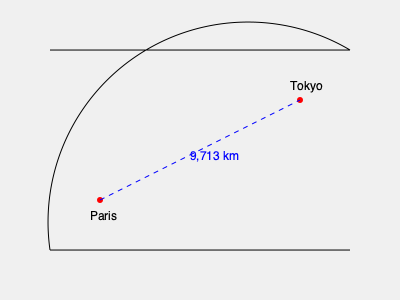Your partner, an avid traveler, is planning a direct flight from Paris to Tokyo. Using the world map provided, which shows the curved surface of the Earth, calculate the approximate great circle distance between these two cities if the scale of the map indicates that 1 cm represents 1,000 km and the straight-line distance on the map is 9.713 cm. To solve this problem, we'll follow these steps:

1. Understand the concept of great circle distance:
   The shortest distance between two points on a sphere (like Earth) follows a great circle path, which appears curved on a flat map.

2. Recognize the given information:
   - The map shows a curved Earth surface
   - Scale: 1 cm on the map = 1,000 km in reality
   - Straight-line distance on the map: 9.713 cm

3. Calculate the great circle distance:
   Since the map already represents the Earth's curvature, we can use the straight-line distance as an approximation of the great circle distance.

   Distance = Map distance × Scale
   $$ \text{Distance} = 9.713 \text{ cm} \times 1,000 \text{ km/cm} $$
   $$ \text{Distance} = 9,713 \text{ km} $$

4. Round the result:
   It's common to round distances to the nearest whole number for practical purposes.

Therefore, the approximate great circle distance between Paris and Tokyo is 9,713 km.
Answer: 9,713 km 